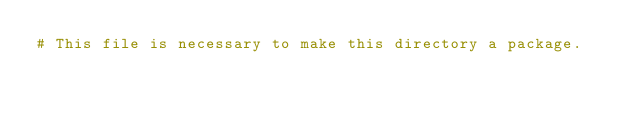<code> <loc_0><loc_0><loc_500><loc_500><_Python_># This file is necessary to make this directory a package.
</code> 